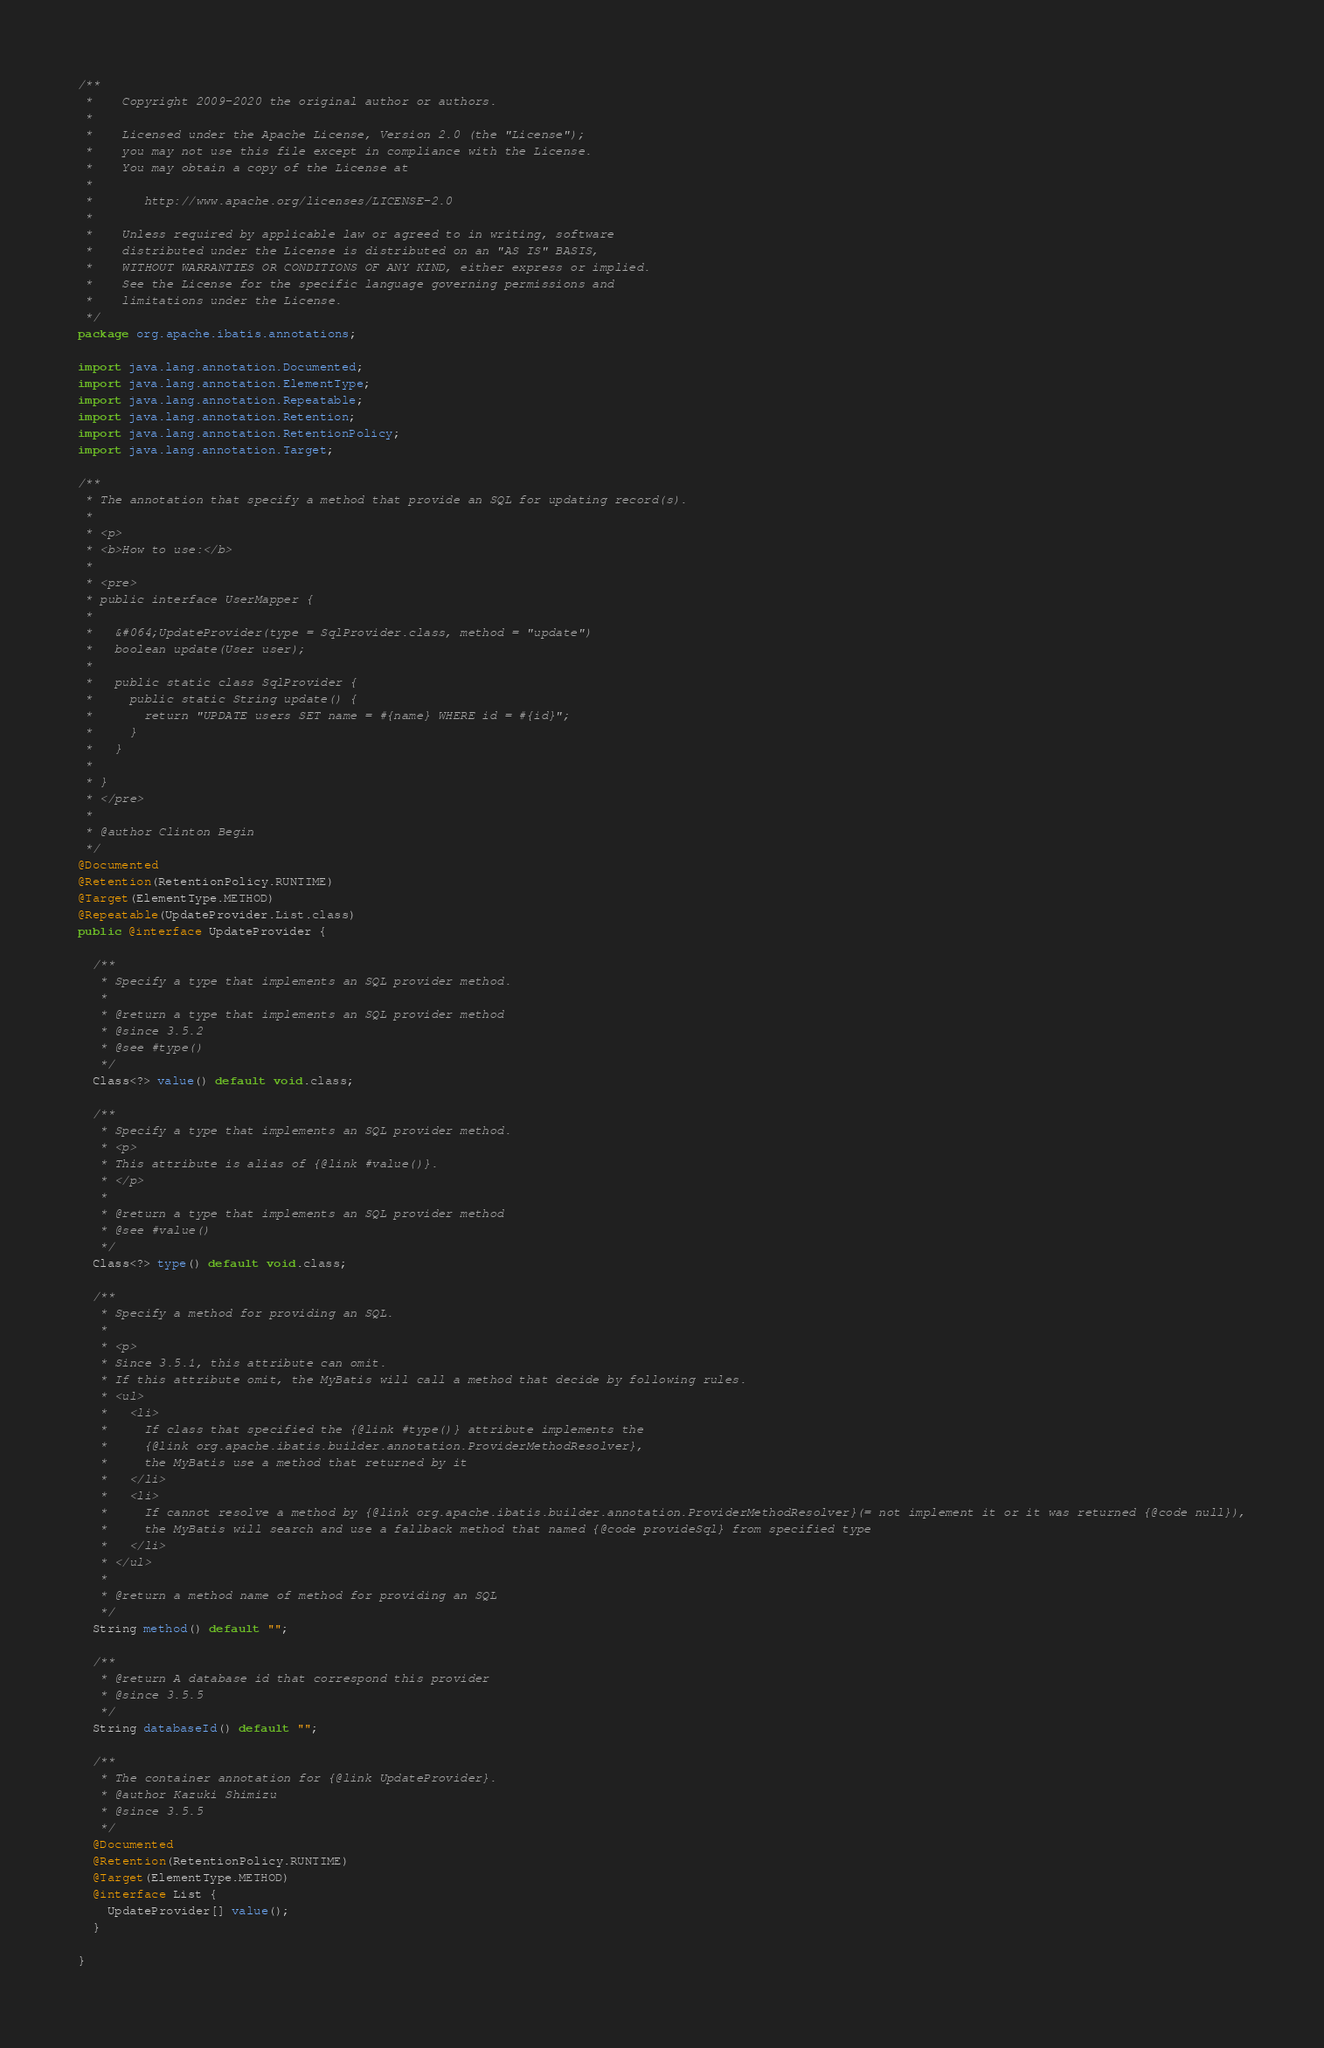<code> <loc_0><loc_0><loc_500><loc_500><_Java_>/**
 *    Copyright 2009-2020 the original author or authors.
 *
 *    Licensed under the Apache License, Version 2.0 (the "License");
 *    you may not use this file except in compliance with the License.
 *    You may obtain a copy of the License at
 *
 *       http://www.apache.org/licenses/LICENSE-2.0
 *
 *    Unless required by applicable law or agreed to in writing, software
 *    distributed under the License is distributed on an "AS IS" BASIS,
 *    WITHOUT WARRANTIES OR CONDITIONS OF ANY KIND, either express or implied.
 *    See the License for the specific language governing permissions and
 *    limitations under the License.
 */
package org.apache.ibatis.annotations;

import java.lang.annotation.Documented;
import java.lang.annotation.ElementType;
import java.lang.annotation.Repeatable;
import java.lang.annotation.Retention;
import java.lang.annotation.RetentionPolicy;
import java.lang.annotation.Target;

/**
 * The annotation that specify a method that provide an SQL for updating record(s).
 *
 * <p>
 * <b>How to use:</b>
 *
 * <pre>
 * public interface UserMapper {
 *
 *   &#064;UpdateProvider(type = SqlProvider.class, method = "update")
 *   boolean update(User user);
 *
 *   public static class SqlProvider {
 *     public static String update() {
 *       return "UPDATE users SET name = #{name} WHERE id = #{id}";
 *     }
 *   }
 *
 * }
 * </pre>
 *
 * @author Clinton Begin
 */
@Documented
@Retention(RetentionPolicy.RUNTIME)
@Target(ElementType.METHOD)
@Repeatable(UpdateProvider.List.class)
public @interface UpdateProvider {

  /**
   * Specify a type that implements an SQL provider method.
   *
   * @return a type that implements an SQL provider method
   * @since 3.5.2
   * @see #type()
   */
  Class<?> value() default void.class;

  /**
   * Specify a type that implements an SQL provider method.
   * <p>
   * This attribute is alias of {@link #value()}.
   * </p>
   *
   * @return a type that implements an SQL provider method
   * @see #value()
   */
  Class<?> type() default void.class;

  /**
   * Specify a method for providing an SQL.
   *
   * <p>
   * Since 3.5.1, this attribute can omit.
   * If this attribute omit, the MyBatis will call a method that decide by following rules.
   * <ul>
   *   <li>
   *     If class that specified the {@link #type()} attribute implements the
   *     {@link org.apache.ibatis.builder.annotation.ProviderMethodResolver},
   *     the MyBatis use a method that returned by it
   *   </li>
   *   <li>
   *     If cannot resolve a method by {@link org.apache.ibatis.builder.annotation.ProviderMethodResolver}(= not implement it or it was returned {@code null}),
   *     the MyBatis will search and use a fallback method that named {@code provideSql} from specified type
   *   </li>
   * </ul>
   *
   * @return a method name of method for providing an SQL
   */
  String method() default "";

  /**
   * @return A database id that correspond this provider
   * @since 3.5.5
   */
  String databaseId() default "";

  /**
   * The container annotation for {@link UpdateProvider}.
   * @author Kazuki Shimizu
   * @since 3.5.5
   */
  @Documented
  @Retention(RetentionPolicy.RUNTIME)
  @Target(ElementType.METHOD)
  @interface List {
    UpdateProvider[] value();
  }

}
</code> 